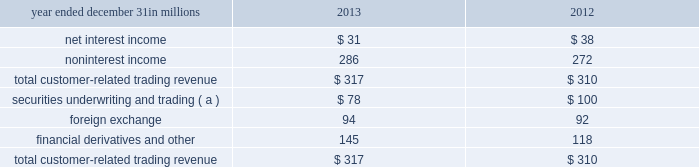Simulations assume that as assets and liabilities mature , they are replaced or repriced at then current market rates .
We also consider forward projections of purchase accounting accretion when forecasting net interest income .
The following graph presents the libor/swap yield curves for the base rate scenario and each of the alternate scenarios one year forward .
Table 52 : alternate interest rate scenarios : one year forward base rates pnc economist market forward slope flattening 2y 3y 5y 10y the fourth quarter 2013 interest sensitivity analyses indicate that our consolidated balance sheet is positioned to benefit from an increase in interest rates and an upward sloping interest rate yield curve .
We believe that we have the deposit funding base and balance sheet flexibility to adjust , where appropriate and permissible , to changing interest rates and market conditions .
Market risk management 2013 customer-related trading risk we engage in fixed income securities , derivatives and foreign exchange transactions to support our customers 2019 investing and hedging activities .
These transactions , related hedges and the credit valuation adjustment ( cva ) related to our customer derivatives portfolio are marked-to-market on a daily basis and reported as customer-related trading activities .
We do not engage in proprietary trading of these products .
We use value-at-risk ( var ) as the primary means to measure and monitor market risk in customer-related trading activities .
We calculate a diversified var at a 95% ( 95 % ) confidence interval .
Var is used to estimate the probability of portfolio losses based on the statistical analysis of historical market risk factors .
A diversified var reflects empirical correlations across different asset classes .
During 2013 , our 95% ( 95 % ) var ranged between $ 1.7 million and $ 5.5 million , averaging $ 3.5 million .
During 2012 , our 95% ( 95 % ) var ranged between $ 1.1 million and $ 5.3 million , averaging $ 3.2 million .
To help ensure the integrity of the models used to calculate var for each portfolio and enterprise-wide , we use a process known as backtesting .
The backtesting process consists of comparing actual observations of gains or losses against the var levels that were calculated at the close of the prior day .
This assumes that market exposures remain constant throughout the day and that recent historical market variability is a good predictor of future variability .
Our customer-related trading activity includes customer revenue and intraday hedging which helps to reduce losses , and may reduce the number of instances of actual losses exceeding the prior day var measure .
There was one such instance during 2013 under our diversified var measure where actual losses exceeded the prior day var measure .
In comparison , there were two such instances during 2012 .
We use a 500 day look back period for backtesting and include customer-related revenue .
The following graph shows a comparison of enterprise-wide gains and losses against prior day diversified var for the period indicated .
Table 53 : enterprise-wide gains/losses versus value-at- 12/31/12 1/31/13 2/28/13 3/31/13 4/30/13 5/31/13 6/30/13 7/31/13 8/31/13 9/30/13 10/31/13 11/30/13 12/31/13 total customer-related trading revenue was as follows : table 54 : customer-related trading revenue year ended december 31 in millions 2013 2012 .
( a ) includes changes in fair value for certain loans accounted for at fair value .
Customer-related trading revenues for 2013 increased $ 7 million compared with 2012 .
The increase primarily resulted from the impact of higher market interest rates on credit valuations for customer-related derivatives activities and improved debt underwriting results which were partially offset by reduced client sales revenue .
The pnc financial services group , inc .
2013 form 10-k 93 .
For 2012 and 2013 , what was average foreign exchange income in millions? 
Computations: table_average(foreign exchange, none)
Answer: 93.0. 